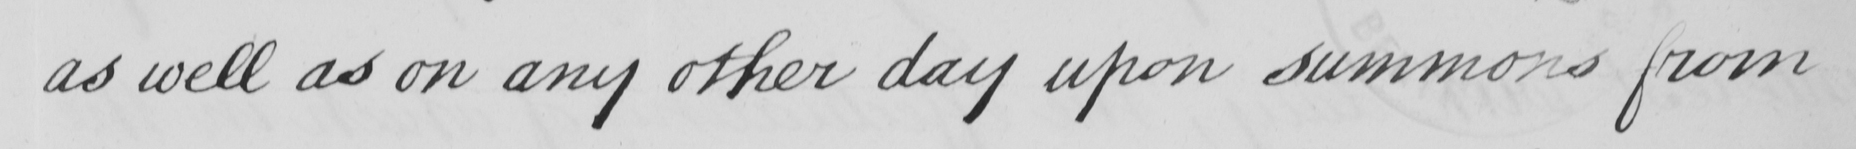What is written in this line of handwriting? as well as on any other day upon summons from 